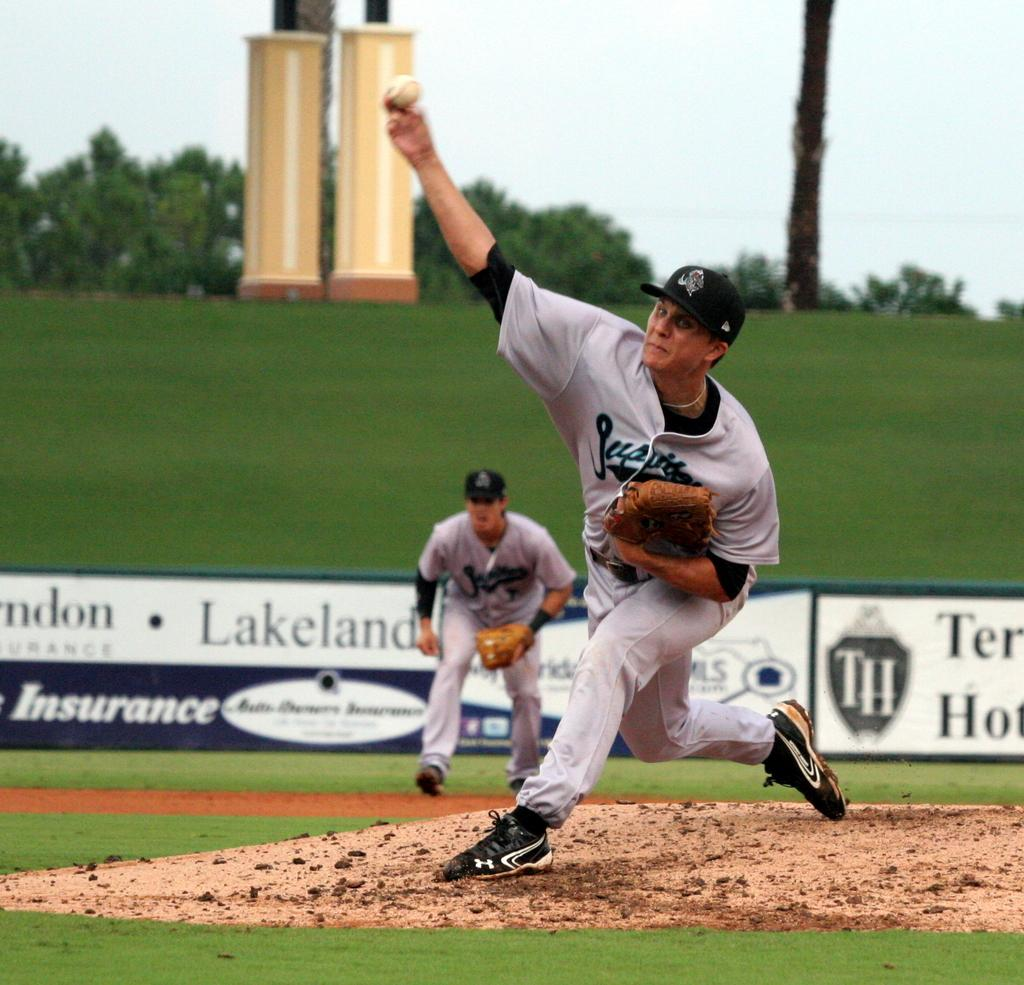Provide a one-sentence caption for the provided image. Two men playing baseball with the word Lakeland behind one of them. 